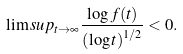Convert formula to latex. <formula><loc_0><loc_0><loc_500><loc_500>\lim s u p _ { t \to \infty } \frac { \log f ( t ) } { \left ( \log t \right ) ^ { 1 / 2 } } < 0 .</formula> 